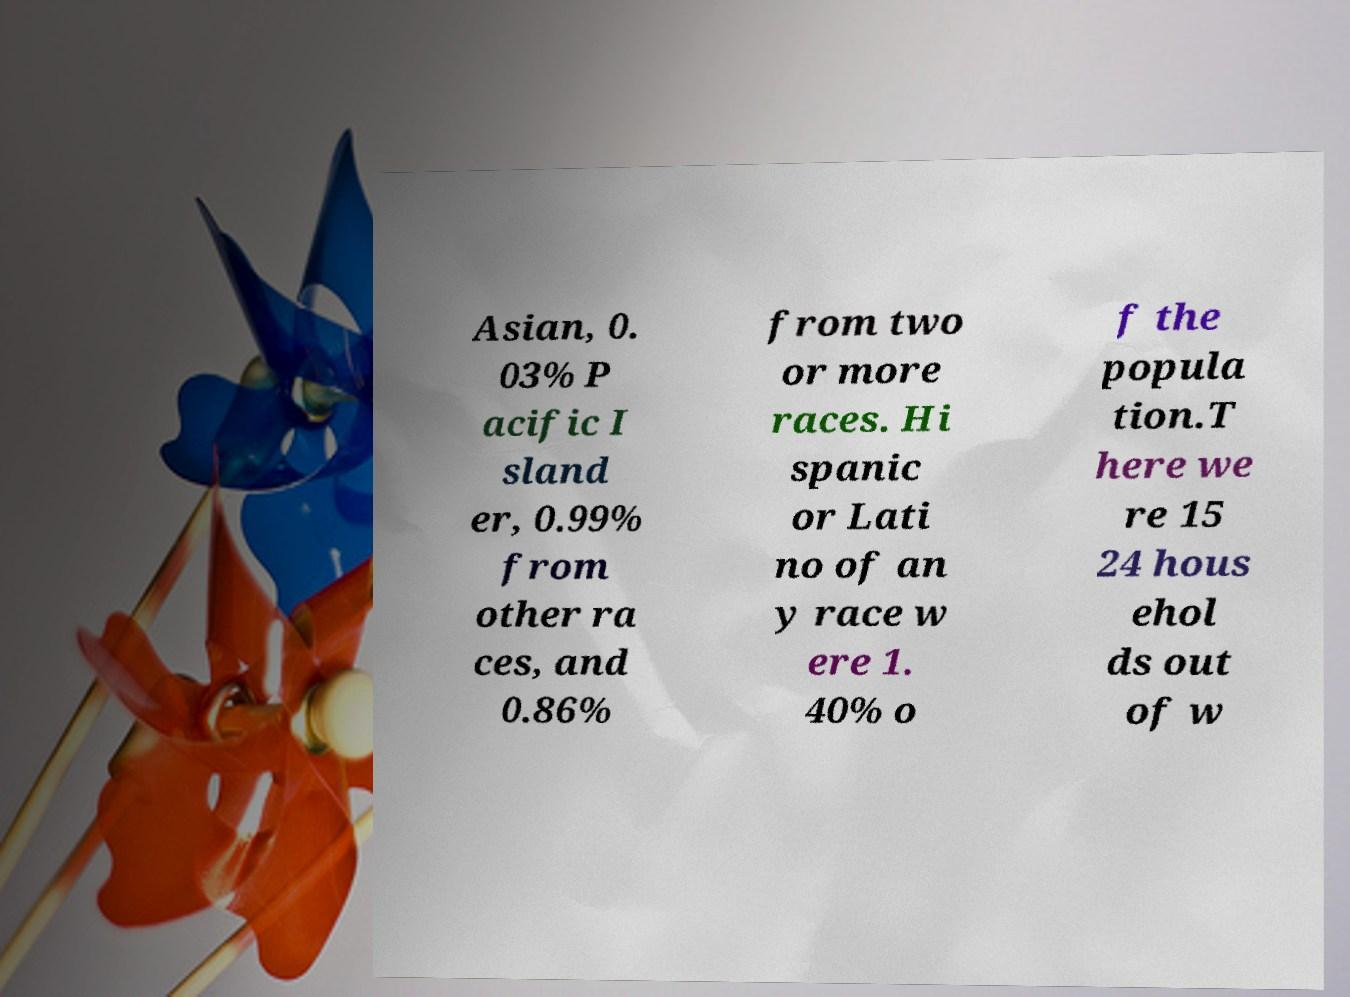I need the written content from this picture converted into text. Can you do that? Asian, 0. 03% P acific I sland er, 0.99% from other ra ces, and 0.86% from two or more races. Hi spanic or Lati no of an y race w ere 1. 40% o f the popula tion.T here we re 15 24 hous ehol ds out of w 